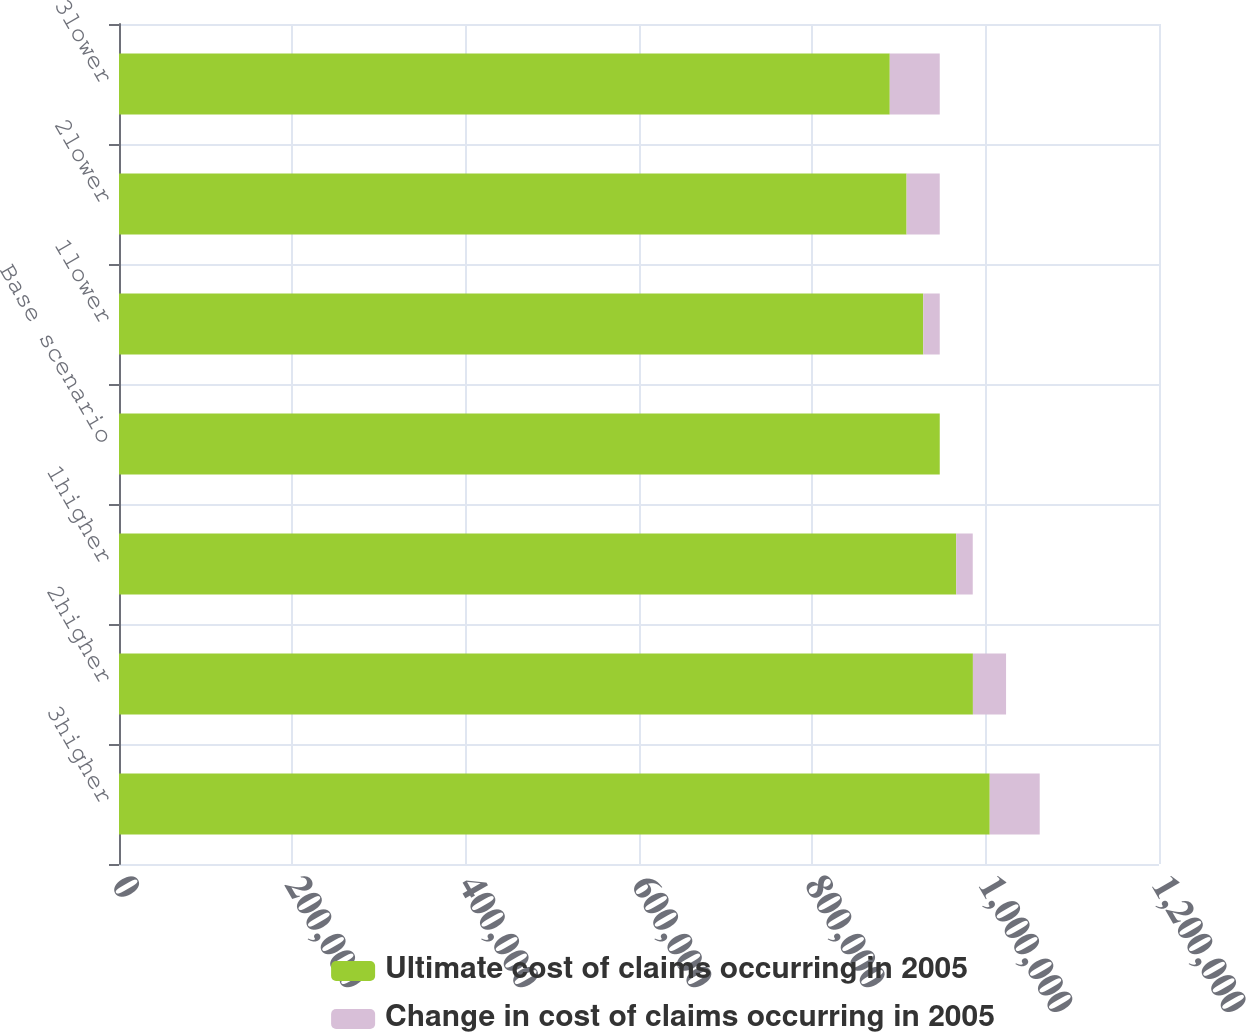Convert chart to OTSL. <chart><loc_0><loc_0><loc_500><loc_500><stacked_bar_chart><ecel><fcel>3higher<fcel>2higher<fcel>1higher<fcel>Base scenario<fcel>1lower<fcel>2lower<fcel>3lower<nl><fcel>Ultimate cost of claims occurring in 2005<fcel>1.00469e+06<fcel>985278<fcel>966053<fcel>947018<fcel>927983<fcel>908758<fcel>889345<nl><fcel>Change in cost of claims occurring in 2005<fcel>57673<fcel>38260<fcel>19035<fcel>0<fcel>19035<fcel>38260<fcel>57673<nl></chart> 